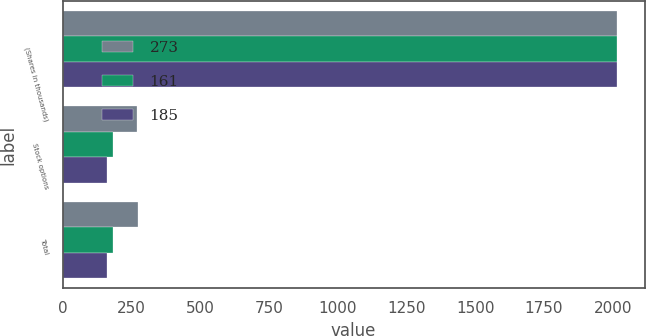Convert chart to OTSL. <chart><loc_0><loc_0><loc_500><loc_500><stacked_bar_chart><ecel><fcel>(Shares in thousands)<fcel>Stock options<fcel>Total<nl><fcel>273<fcel>2016<fcel>272<fcel>273<nl><fcel>161<fcel>2015<fcel>185<fcel>185<nl><fcel>185<fcel>2014<fcel>161<fcel>161<nl></chart> 